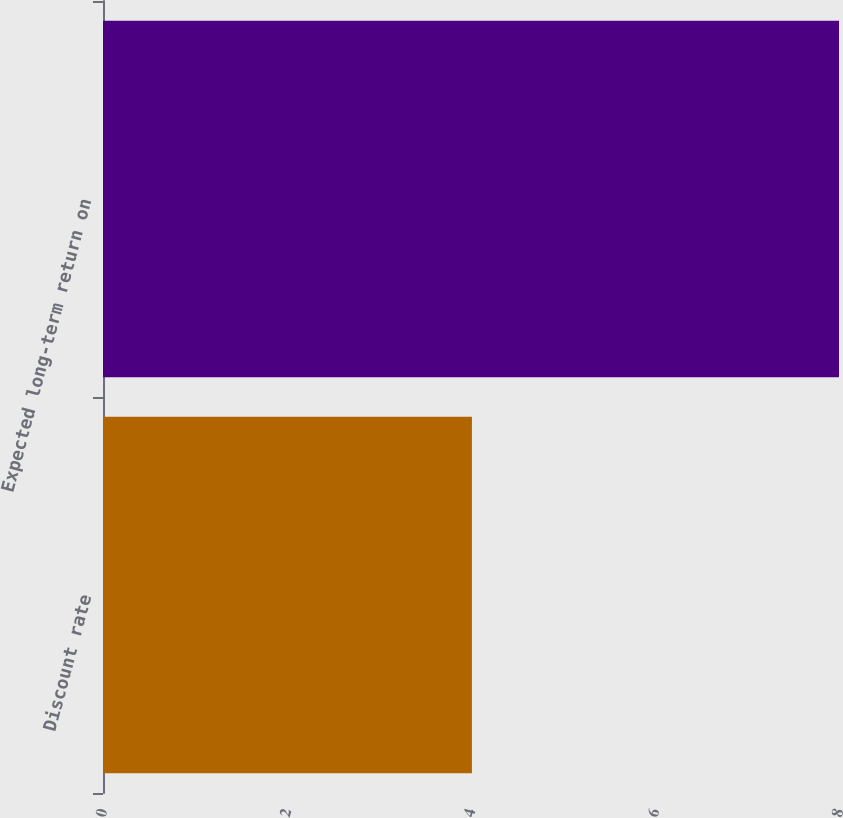Convert chart to OTSL. <chart><loc_0><loc_0><loc_500><loc_500><bar_chart><fcel>Discount rate<fcel>Expected long-term return on<nl><fcel>4.01<fcel>8<nl></chart> 